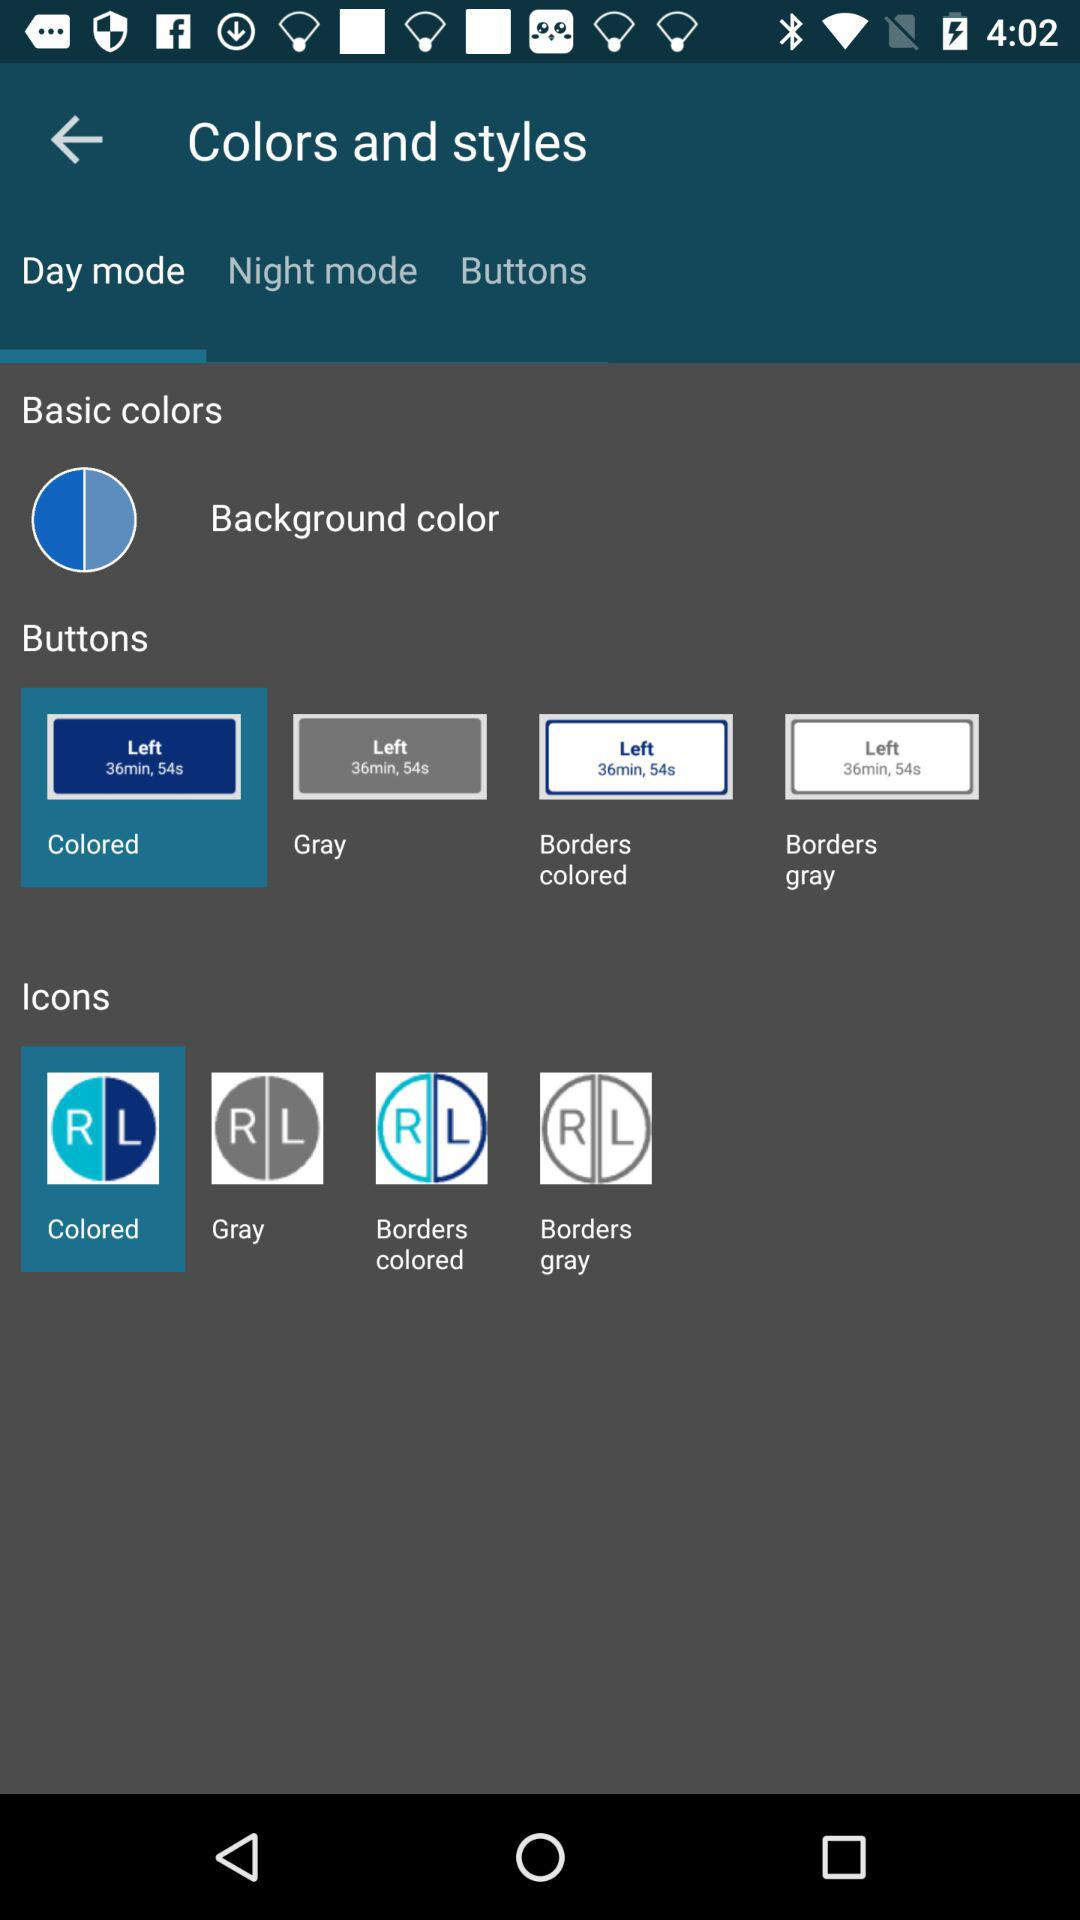Which option is selected in "Icons"? The selected option is "Colored". 